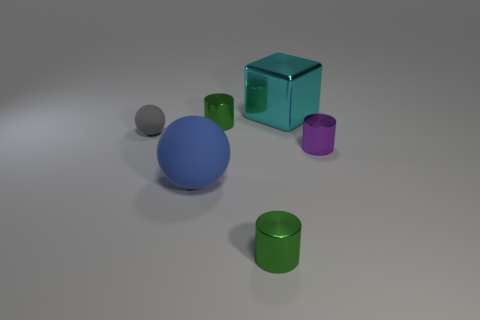Add 1 big cyan metal cubes. How many objects exist? 7 Subtract all cubes. How many objects are left? 5 Subtract 0 purple balls. How many objects are left? 6 Subtract all large blue things. Subtract all tiny metal cylinders. How many objects are left? 2 Add 6 green metallic cylinders. How many green metallic cylinders are left? 8 Add 2 cyan blocks. How many cyan blocks exist? 3 